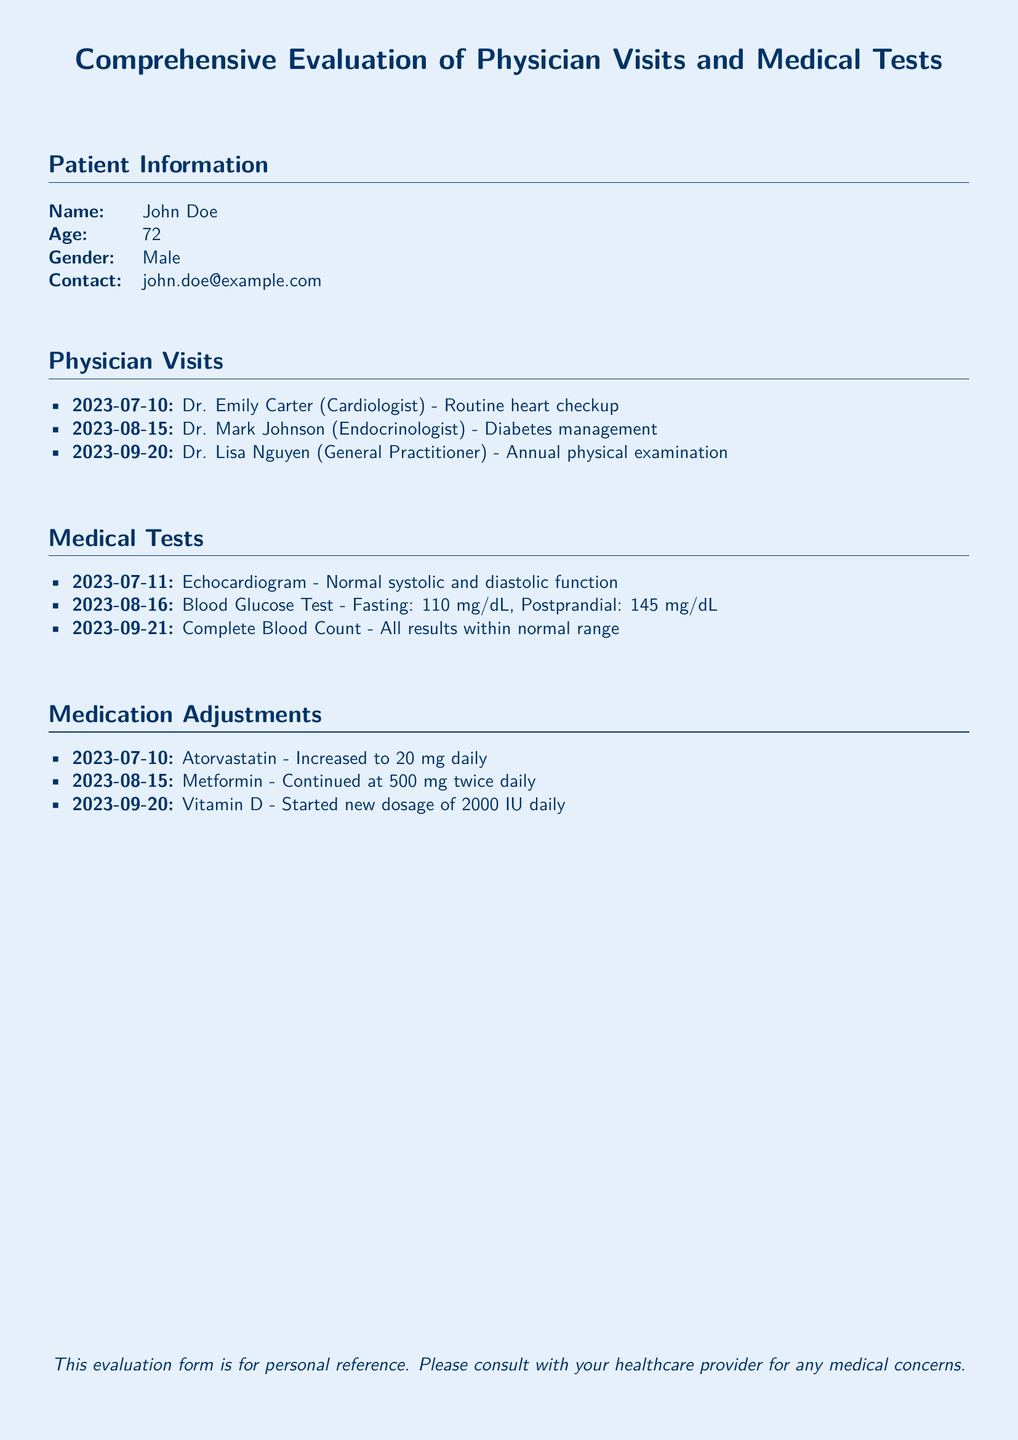What is the name of the cardiologist visited? The document lists Dr. Emily Carter as the cardiologist who was visited on July 10, 2023.
Answer: Dr. Emily Carter What was the date of the blood glucose test? The blood glucose test was conducted on August 16, 2023, as mentioned in the medical tests section.
Answer: 2023-08-16 How many physician visits are recorded in the document? The document lists three physician visits under the Physician Visits section.
Answer: 3 What adjustment was made to Atorvastatin? The form states that Atorvastatin was increased to 20 mg daily on July 10, 2023.
Answer: Increased to 20 mg daily Which test showed results within the normal range? The Complete Blood Count conducted on September 21, 2023, showed all results within normal range.
Answer: Complete Blood Count Who conducted the annual physical examination? The annual physical examination was conducted by Dr. Lisa Nguyen according to the visits listed.
Answer: Dr. Lisa Nguyen What medication is continued at 500 mg twice daily? The document indicates that Metformin is continued at this dosage.
Answer: Metformin What is the new dosage for Vitamin D? The new dosage for Vitamin D, which began on September 20, 2023, is stated as 2000 IU daily.
Answer: 2000 IU daily 